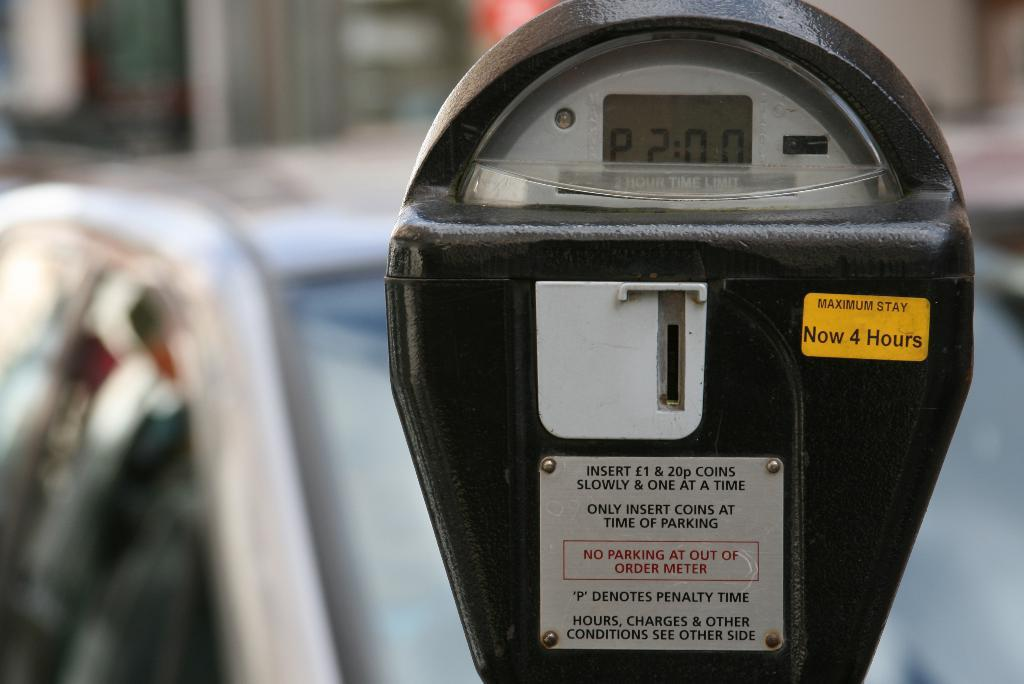<image>
Give a short and clear explanation of the subsequent image. A parking meter with a four hour maximum shows two hours remaining on the display screen. 